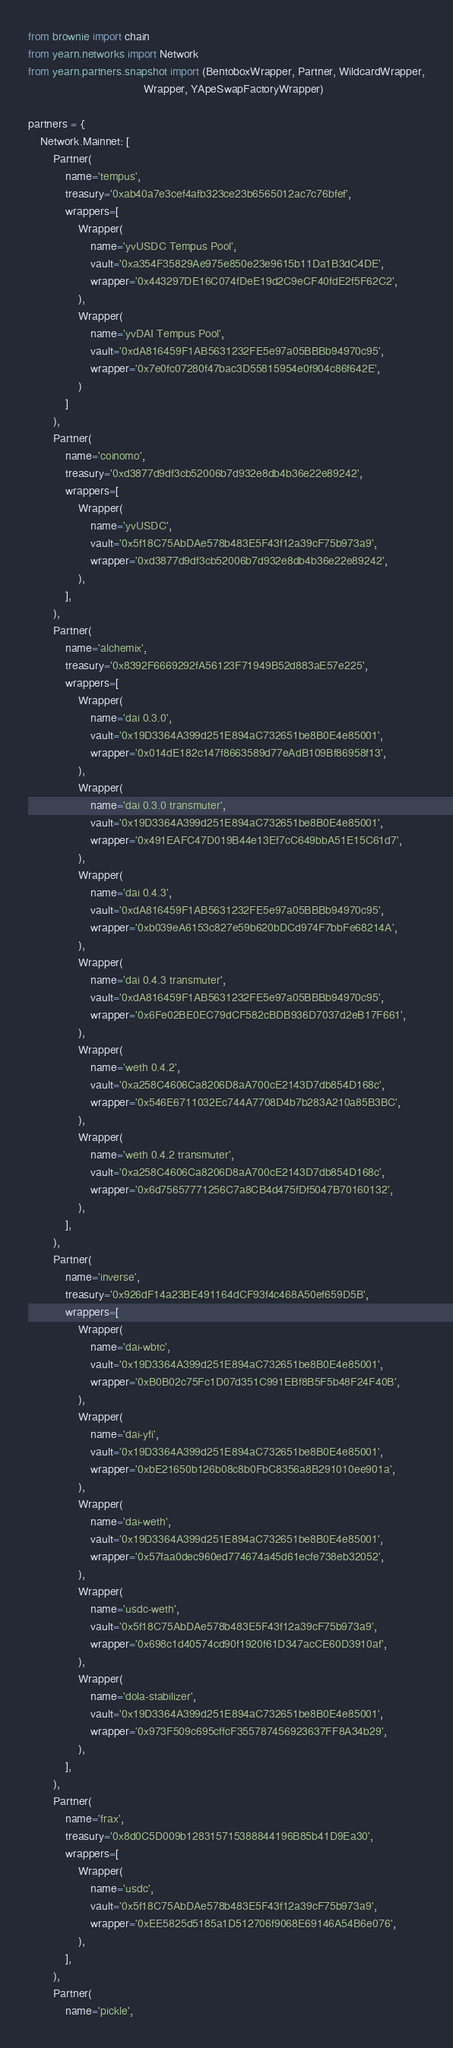Convert code to text. <code><loc_0><loc_0><loc_500><loc_500><_Python_>from brownie import chain
from yearn.networks import Network
from yearn.partners.snapshot import (BentoboxWrapper, Partner, WildcardWrapper,
                                     Wrapper, YApeSwapFactoryWrapper)

partners = {
    Network.Mainnet: [
        Partner(
            name='tempus',
            treasury='0xab40a7e3cef4afb323ce23b6565012ac7c76bfef',
            wrappers=[
                Wrapper(
                    name='yvUSDC Tempus Pool',
                    vault='0xa354F35829Ae975e850e23e9615b11Da1B3dC4DE',
                    wrapper='0x443297DE16C074fDeE19d2C9eCF40fdE2f5F62C2',
                ),
                Wrapper(
                    name='yvDAI Tempus Pool',
                    vault='0xdA816459F1AB5631232FE5e97a05BBBb94970c95',
                    wrapper='0x7e0fc07280f47bac3D55815954e0f904c86f642E',
                )
            ]
        ),
        Partner(
            name='coinomo',
            treasury='0xd3877d9df3cb52006b7d932e8db4b36e22e89242',
            wrappers=[
                Wrapper(
                    name='yvUSDC',
                    vault='0x5f18C75AbDAe578b483E5F43f12a39cF75b973a9',
                    wrapper='0xd3877d9df3cb52006b7d932e8db4b36e22e89242',
                ),
            ],
        ),
        Partner(
            name='alchemix',
            treasury='0x8392F6669292fA56123F71949B52d883aE57e225',
            wrappers=[
                Wrapper(
                    name='dai 0.3.0',
                    vault='0x19D3364A399d251E894aC732651be8B0E4e85001',
                    wrapper='0x014dE182c147f8663589d77eAdB109Bf86958f13',
                ),
                Wrapper(
                    name='dai 0.3.0 transmuter',
                    vault='0x19D3364A399d251E894aC732651be8B0E4e85001',
                    wrapper='0x491EAFC47D019B44e13Ef7cC649bbA51E15C61d7',
                ),
                Wrapper(
                    name='dai 0.4.3',
                    vault='0xdA816459F1AB5631232FE5e97a05BBBb94970c95',
                    wrapper='0xb039eA6153c827e59b620bDCd974F7bbFe68214A',
                ),
                Wrapper(
                    name='dai 0.4.3 transmuter',
                    vault='0xdA816459F1AB5631232FE5e97a05BBBb94970c95',
                    wrapper='0x6Fe02BE0EC79dCF582cBDB936D7037d2eB17F661',
                ),
                Wrapper(
                    name='weth 0.4.2',
                    vault='0xa258C4606Ca8206D8aA700cE2143D7db854D168c',
                    wrapper='0x546E6711032Ec744A7708D4b7b283A210a85B3BC',
                ),
                Wrapper(
                    name='weth 0.4.2 transmuter',
                    vault='0xa258C4606Ca8206D8aA700cE2143D7db854D168c',
                    wrapper='0x6d75657771256C7a8CB4d475fDf5047B70160132',
                ),
            ],
        ),
        Partner(
            name='inverse',
            treasury='0x926dF14a23BE491164dCF93f4c468A50ef659D5B',
            wrappers=[
                Wrapper(
                    name='dai-wbtc',
                    vault='0x19D3364A399d251E894aC732651be8B0E4e85001',
                    wrapper='0xB0B02c75Fc1D07d351C991EBf8B5F5b48F24F40B',
                ),
                Wrapper(
                    name='dai-yfi',
                    vault='0x19D3364A399d251E894aC732651be8B0E4e85001',
                    wrapper='0xbE21650b126b08c8b0FbC8356a8B291010ee901a',
                ),
                Wrapper(
                    name='dai-weth',
                    vault='0x19D3364A399d251E894aC732651be8B0E4e85001',
                    wrapper='0x57faa0dec960ed774674a45d61ecfe738eb32052',
                ),
                Wrapper(
                    name='usdc-weth',
                    vault='0x5f18C75AbDAe578b483E5F43f12a39cF75b973a9',
                    wrapper='0x698c1d40574cd90f1920f61D347acCE60D3910af',
                ),
                Wrapper(
                    name='dola-stabilizer',
                    vault='0x19D3364A399d251E894aC732651be8B0E4e85001',
                    wrapper='0x973F509c695cffcF355787456923637FF8A34b29',
                ),
            ],
        ),
        Partner(
            name='frax',
            treasury='0x8d0C5D009b128315715388844196B85b41D9Ea30',
            wrappers=[
                Wrapper(
                    name='usdc',
                    vault='0x5f18C75AbDAe578b483E5F43f12a39cF75b973a9',
                    wrapper='0xEE5825d5185a1D512706f9068E69146A54B6e076',
                ),
            ],
        ),
        Partner(
            name='pickle',</code> 